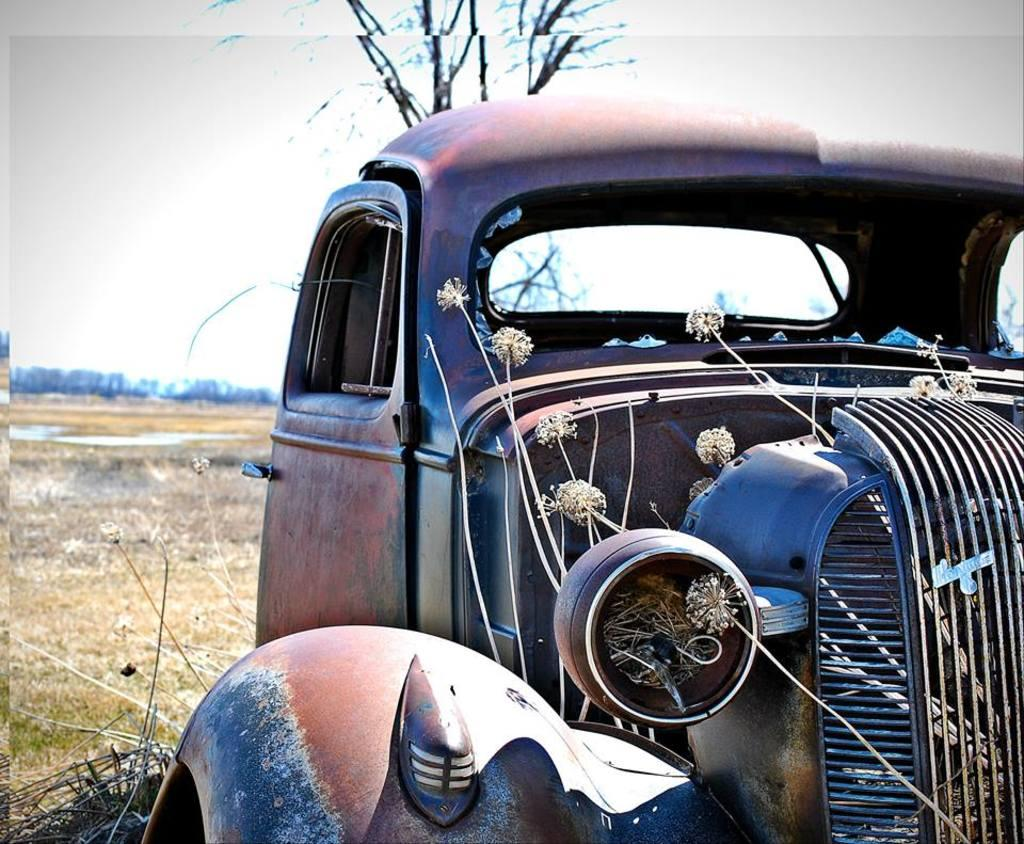What is the main subject of the image? The main subject of the image is a car. Can you describe the car in the image? The car appears to be vintage. What type of terrain is visible in the image? There is grass on the ground in the image. What can be seen in the background of the image? There are trees in the background of the image. What is visible at the top of the image? The sky is visible at the top of the image. How many goldfish can be seen swimming in the image? There are no goldfish present in the image. What type of wave is depicted in the image? There is no wave depicted in the image; it features a vintage car, grass, trees, and the sky. 